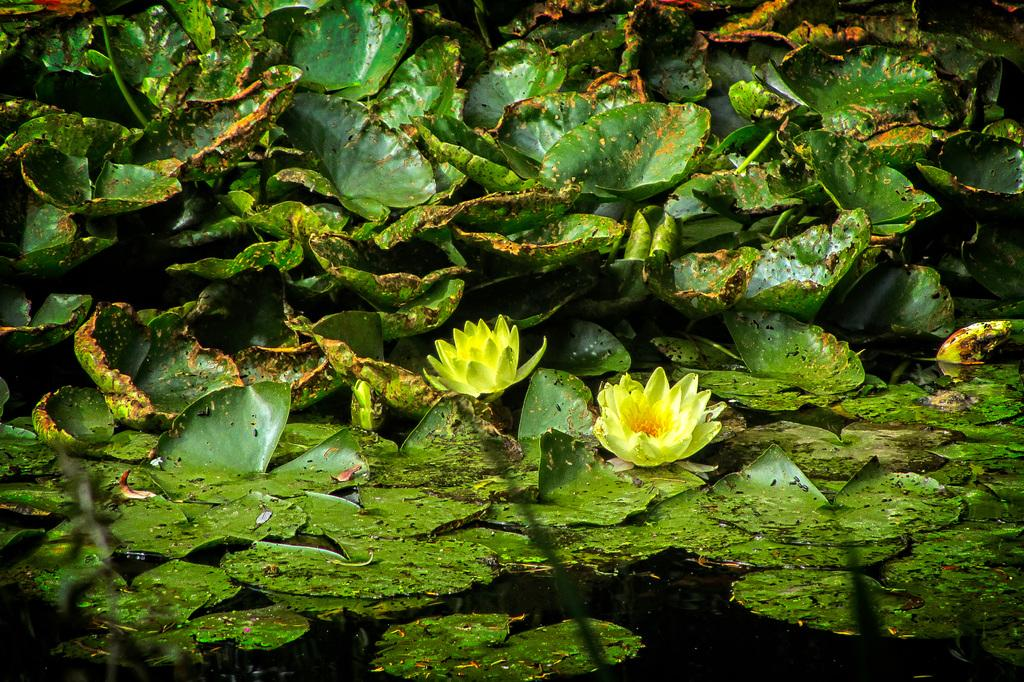How many lotus flowers are in the image? There are two lotus flowers in the image. What color are the lotus flowers? The lotus flowers are yellow in color. What else can be seen floating on the water in the image? There are green leaves floating on the water in the image. What color are the leaves? The leaves are green in color. What type of line can be seen connecting the two lotus flowers in the image? There is no line connecting the two lotus flowers in the image. Can you tell me how many groups of lotus flowers are present in the image? There is only one group of lotus flowers in the image, as there are two flowers together. 